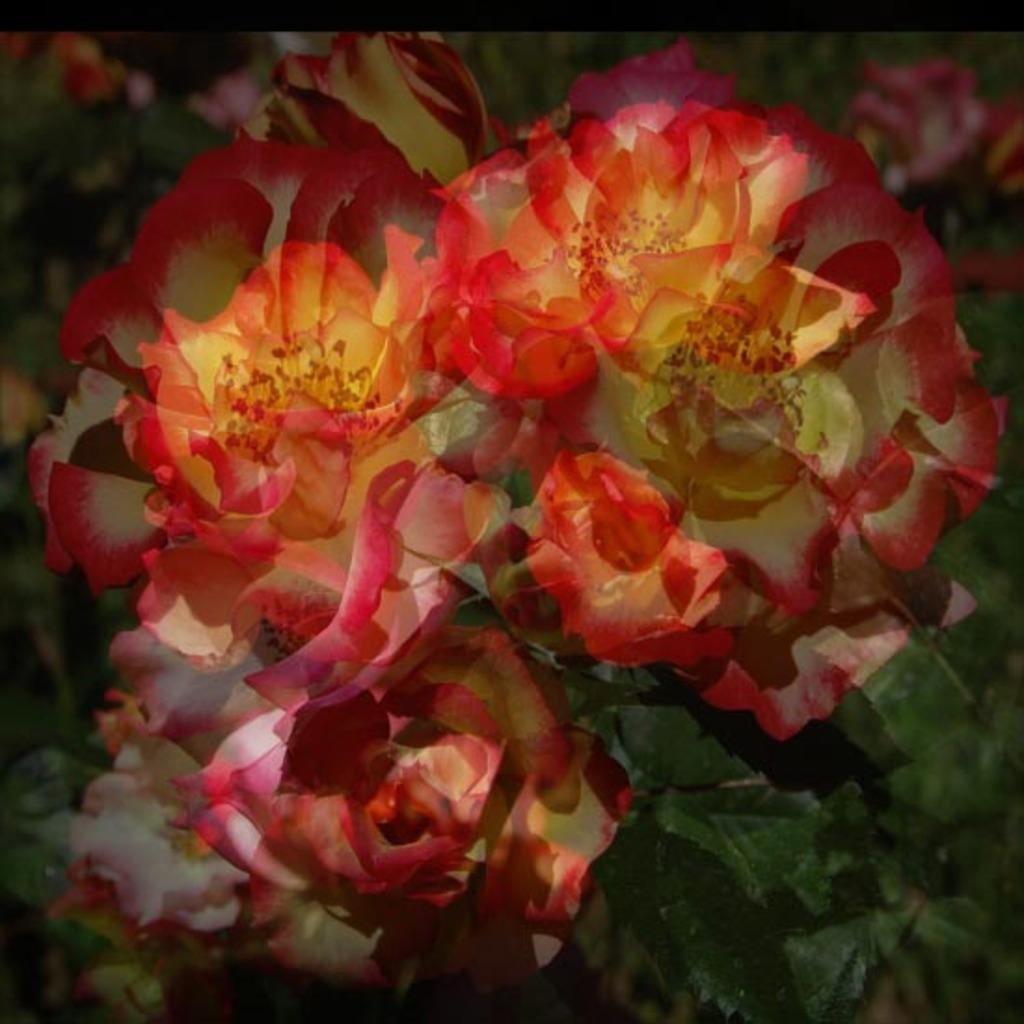What type of plant life can be seen in the image? There are flowers and leaves in the image. Can you describe the flowers in the image? Unfortunately, the facts provided do not give specific details about the flowers. What is the color of the leaves in the image? The facts provided do not give specific details about the color of the leaves. What type of beam is holding up the top of the image? There is no beam or top present in the image; it only contains flowers and leaves. 